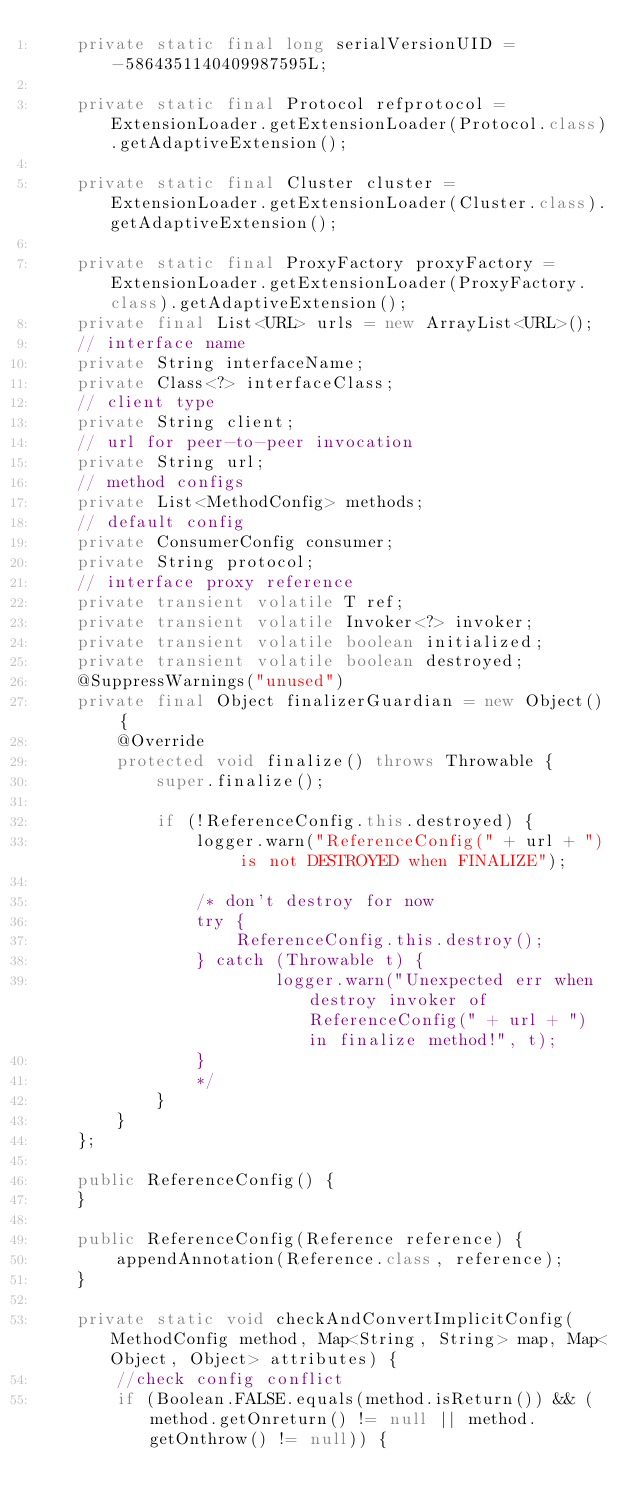Convert code to text. <code><loc_0><loc_0><loc_500><loc_500><_Java_>    private static final long serialVersionUID = -5864351140409987595L;

    private static final Protocol refprotocol = ExtensionLoader.getExtensionLoader(Protocol.class).getAdaptiveExtension();

    private static final Cluster cluster = ExtensionLoader.getExtensionLoader(Cluster.class).getAdaptiveExtension();

    private static final ProxyFactory proxyFactory = ExtensionLoader.getExtensionLoader(ProxyFactory.class).getAdaptiveExtension();
    private final List<URL> urls = new ArrayList<URL>();
    // interface name
    private String interfaceName;
    private Class<?> interfaceClass;
    // client type
    private String client;
    // url for peer-to-peer invocation
    private String url;
    // method configs
    private List<MethodConfig> methods;
    // default config
    private ConsumerConfig consumer;
    private String protocol;
    // interface proxy reference
    private transient volatile T ref;
    private transient volatile Invoker<?> invoker;
    private transient volatile boolean initialized;
    private transient volatile boolean destroyed;
    @SuppressWarnings("unused")
    private final Object finalizerGuardian = new Object() {
        @Override
        protected void finalize() throws Throwable {
            super.finalize();

            if (!ReferenceConfig.this.destroyed) {
                logger.warn("ReferenceConfig(" + url + ") is not DESTROYED when FINALIZE");

                /* don't destroy for now
                try {
                    ReferenceConfig.this.destroy();
                } catch (Throwable t) {
                        logger.warn("Unexpected err when destroy invoker of ReferenceConfig(" + url + ") in finalize method!", t);
                }
                */
            }
        }
    };

    public ReferenceConfig() {
    }

    public ReferenceConfig(Reference reference) {
        appendAnnotation(Reference.class, reference);
    }

    private static void checkAndConvertImplicitConfig(MethodConfig method, Map<String, String> map, Map<Object, Object> attributes) {
        //check config conflict
        if (Boolean.FALSE.equals(method.isReturn()) && (method.getOnreturn() != null || method.getOnthrow() != null)) {</code> 